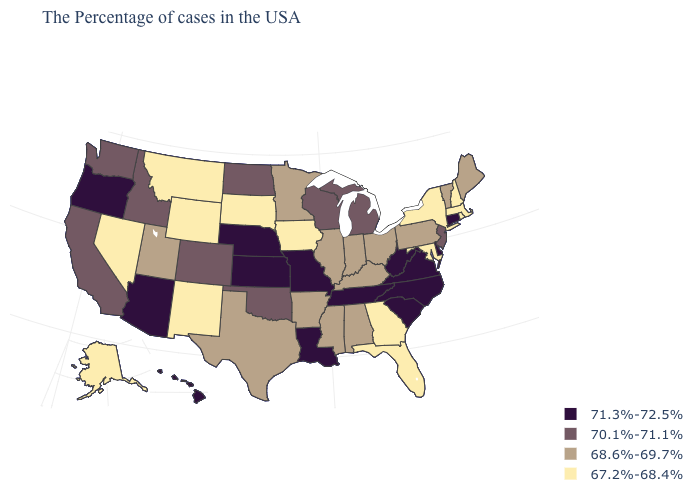Name the states that have a value in the range 67.2%-68.4%?
Be succinct. Massachusetts, Rhode Island, New Hampshire, New York, Maryland, Florida, Georgia, Iowa, South Dakota, Wyoming, New Mexico, Montana, Nevada, Alaska. What is the value of North Carolina?
Quick response, please. 71.3%-72.5%. Name the states that have a value in the range 68.6%-69.7%?
Concise answer only. Maine, Vermont, Pennsylvania, Ohio, Kentucky, Indiana, Alabama, Illinois, Mississippi, Arkansas, Minnesota, Texas, Utah. Does Vermont have the same value as Idaho?
Give a very brief answer. No. Among the states that border Maryland , does Pennsylvania have the lowest value?
Be succinct. Yes. Name the states that have a value in the range 70.1%-71.1%?
Be succinct. New Jersey, Michigan, Wisconsin, Oklahoma, North Dakota, Colorado, Idaho, California, Washington. Does the map have missing data?
Write a very short answer. No. Among the states that border Arkansas , does Oklahoma have the lowest value?
Write a very short answer. No. Does Connecticut have the lowest value in the USA?
Quick response, please. No. Does South Dakota have the lowest value in the USA?
Be succinct. Yes. Which states have the highest value in the USA?
Short answer required. Connecticut, Delaware, Virginia, North Carolina, South Carolina, West Virginia, Tennessee, Louisiana, Missouri, Kansas, Nebraska, Arizona, Oregon, Hawaii. Name the states that have a value in the range 71.3%-72.5%?
Write a very short answer. Connecticut, Delaware, Virginia, North Carolina, South Carolina, West Virginia, Tennessee, Louisiana, Missouri, Kansas, Nebraska, Arizona, Oregon, Hawaii. What is the lowest value in states that border Vermont?
Keep it brief. 67.2%-68.4%. Among the states that border California , which have the highest value?
Concise answer only. Arizona, Oregon. 